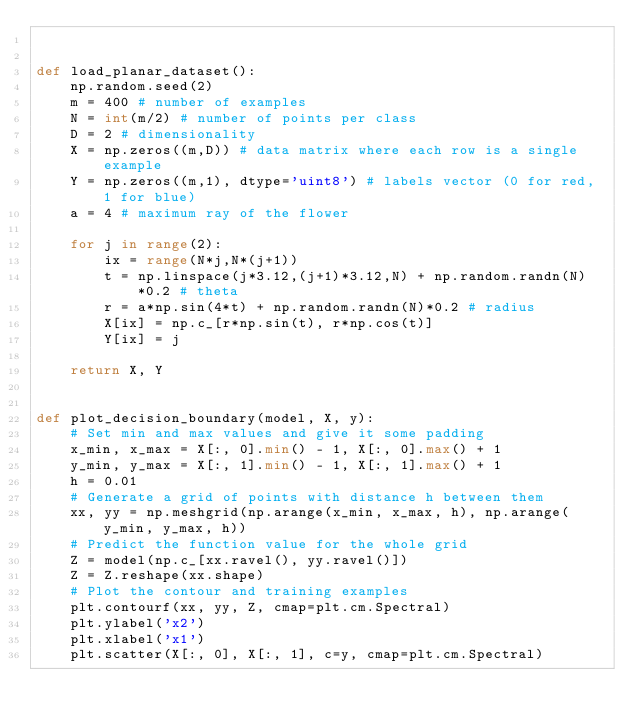Convert code to text. <code><loc_0><loc_0><loc_500><loc_500><_Python_>

def load_planar_dataset():
    np.random.seed(2)
    m = 400 # number of examples
    N = int(m/2) # number of points per class
    D = 2 # dimensionality
    X = np.zeros((m,D)) # data matrix where each row is a single example
    Y = np.zeros((m,1), dtype='uint8') # labels vector (0 for red, 1 for blue)
    a = 4 # maximum ray of the flower

    for j in range(2):
        ix = range(N*j,N*(j+1))
        t = np.linspace(j*3.12,(j+1)*3.12,N) + np.random.randn(N)*0.2 # theta
        r = a*np.sin(4*t) + np.random.randn(N)*0.2 # radius
        X[ix] = np.c_[r*np.sin(t), r*np.cos(t)]
        Y[ix] = j
        
    return X, Y


def plot_decision_boundary(model, X, y):
    # Set min and max values and give it some padding
    x_min, x_max = X[:, 0].min() - 1, X[:, 0].max() + 1
    y_min, y_max = X[:, 1].min() - 1, X[:, 1].max() + 1
    h = 0.01
    # Generate a grid of points with distance h between them
    xx, yy = np.meshgrid(np.arange(x_min, x_max, h), np.arange(y_min, y_max, h))
    # Predict the function value for the whole grid
    Z = model(np.c_[xx.ravel(), yy.ravel()])
    Z = Z.reshape(xx.shape)
    # Plot the contour and training examples
    plt.contourf(xx, yy, Z, cmap=plt.cm.Spectral)
    plt.ylabel('x2')
    plt.xlabel('x1')
    plt.scatter(X[:, 0], X[:, 1], c=y, cmap=plt.cm.Spectral)
</code> 